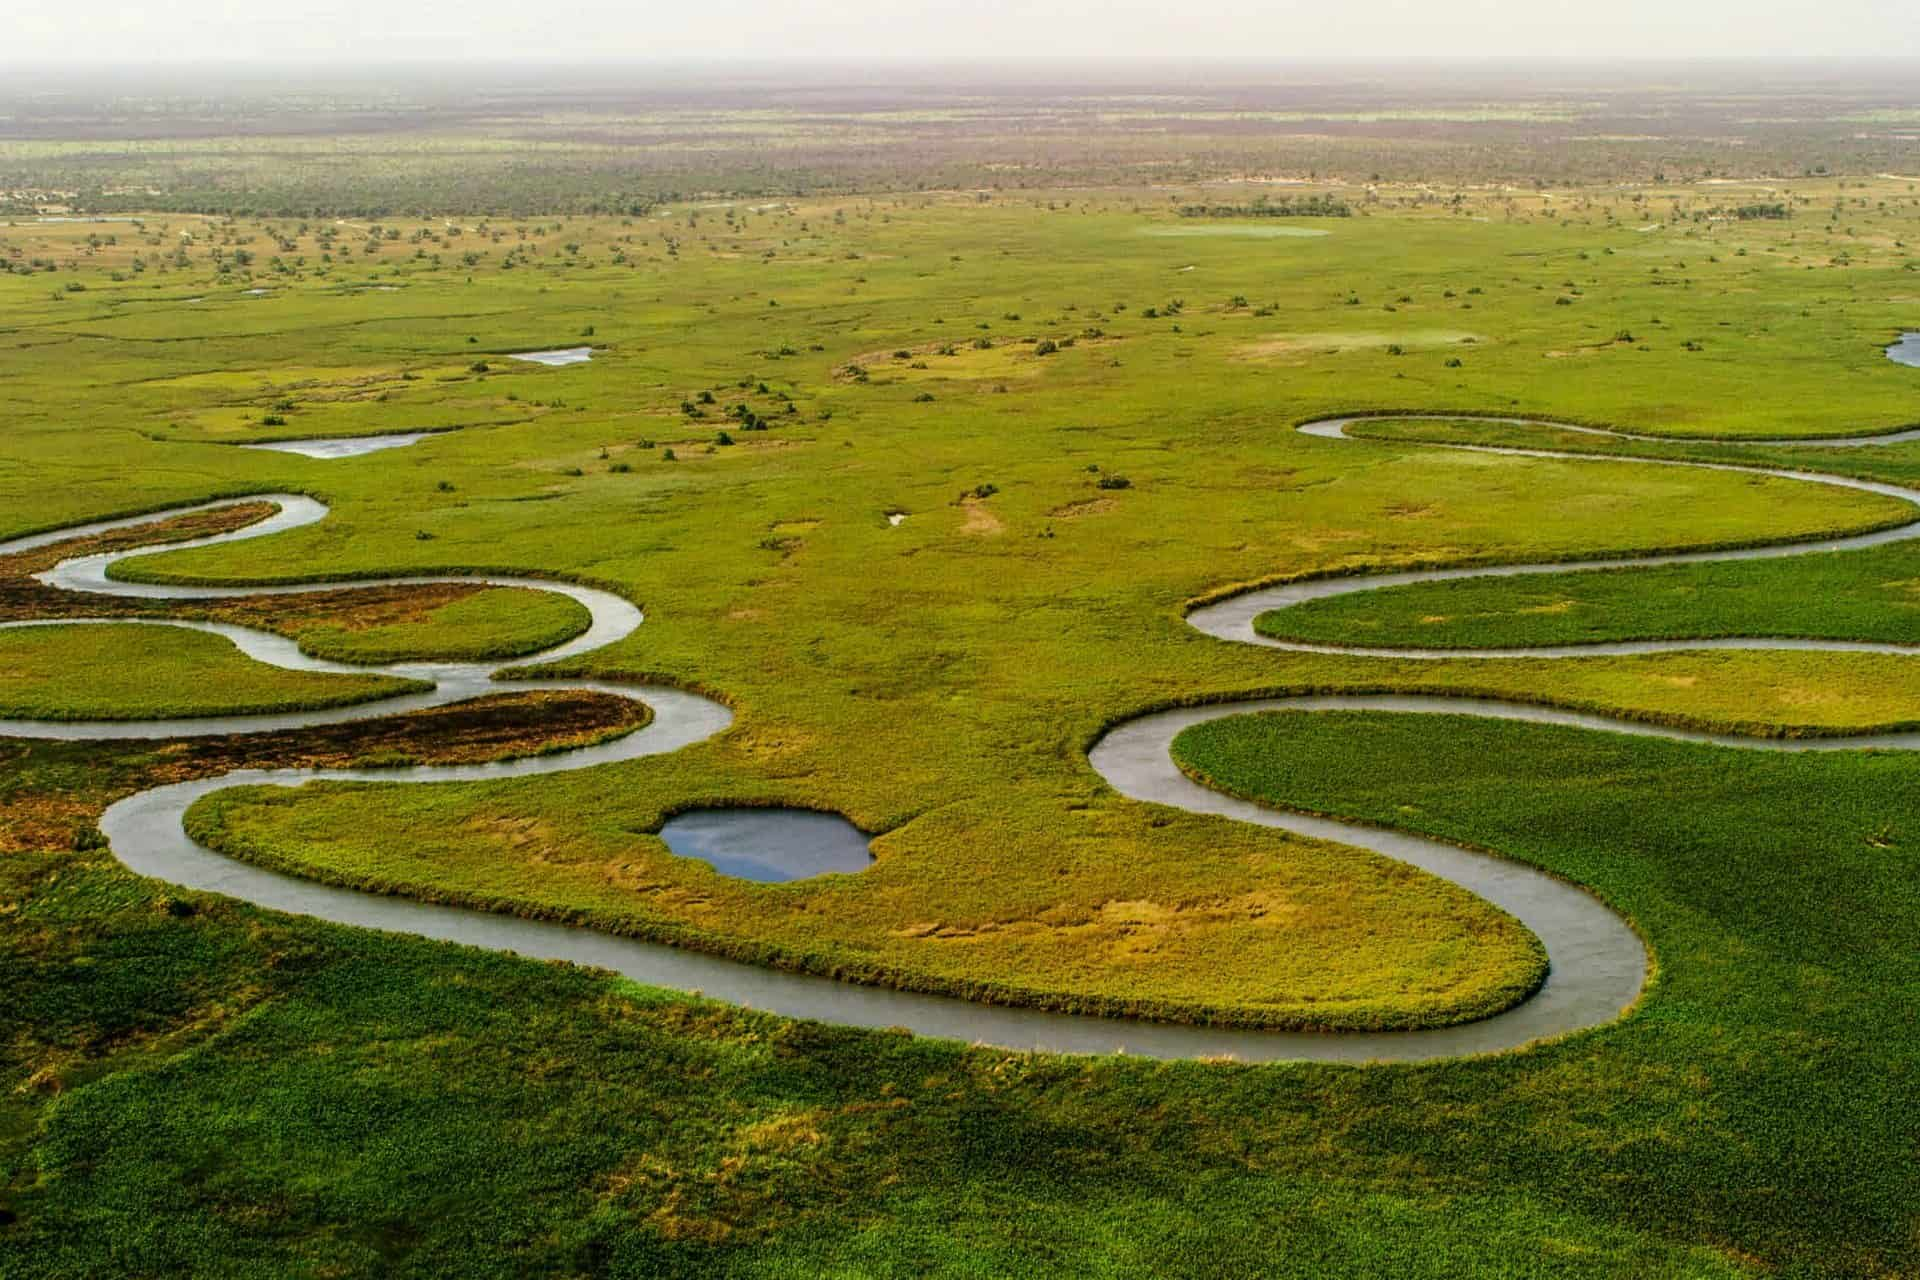What role does the Okavango Delta play in the local ecosystem? The Okavango Delta is a keystone of the regional ecosystem. It provides a vital source of water in an otherwise dry and arid region, creating a lush oasis that supports an incredibly diverse ecosystem. This includes numerous plant species, large predators, and herds of herbivores, as well as fish and invertebrates. It also serves as an important breeding ground for birds, and its waterways and floodplains are crucial for migrating species. The delta's health impacts the overall biological productivity of the area, including human agriculture and fishing communities who rely on its resources. 